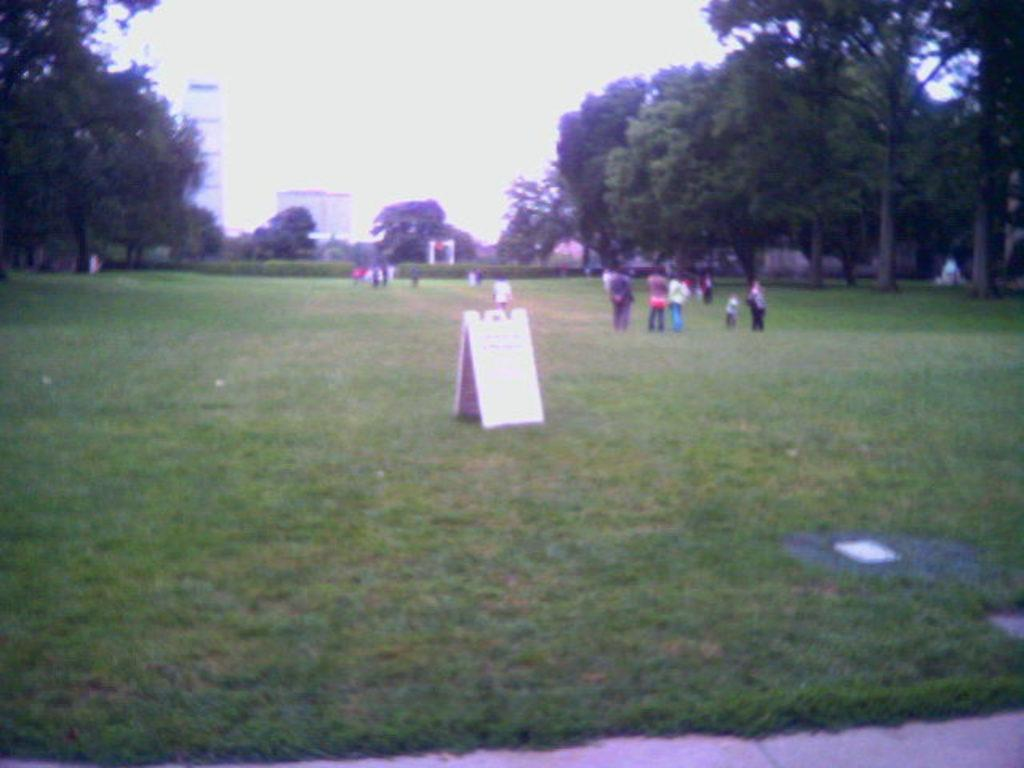What are the people in the image doing? The people in the image are playing in the grass. What object is placed in the grass? A board is placed in the grass. What type of vegetation can be seen in the image? There are trees visible around the area. What structures can be seen in the background? There are buildings visible in the background. What color is the pail that the people are using to show their zippers in the image? There is no pail, no activity involving zippers, and no mention of a pail or zippers in the image. 